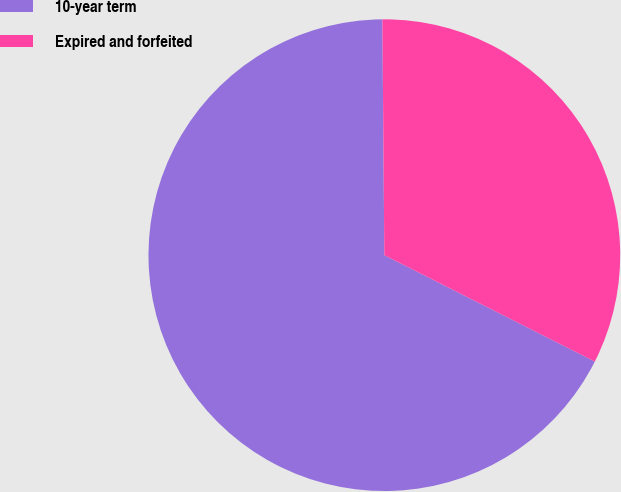Convert chart. <chart><loc_0><loc_0><loc_500><loc_500><pie_chart><fcel>10-year term<fcel>Expired and forfeited<nl><fcel>67.42%<fcel>32.58%<nl></chart> 